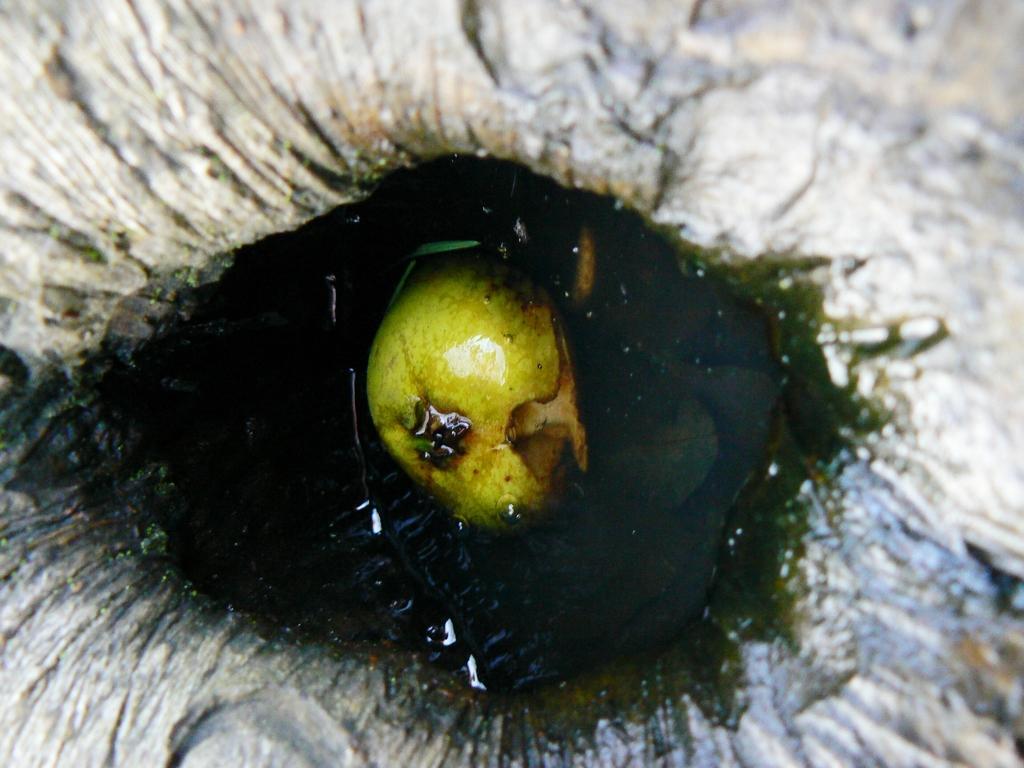In one or two sentences, can you explain what this image depicts? In this water there is an object. 